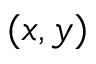<formula> <loc_0><loc_0><loc_500><loc_500>( x , y )</formula> 